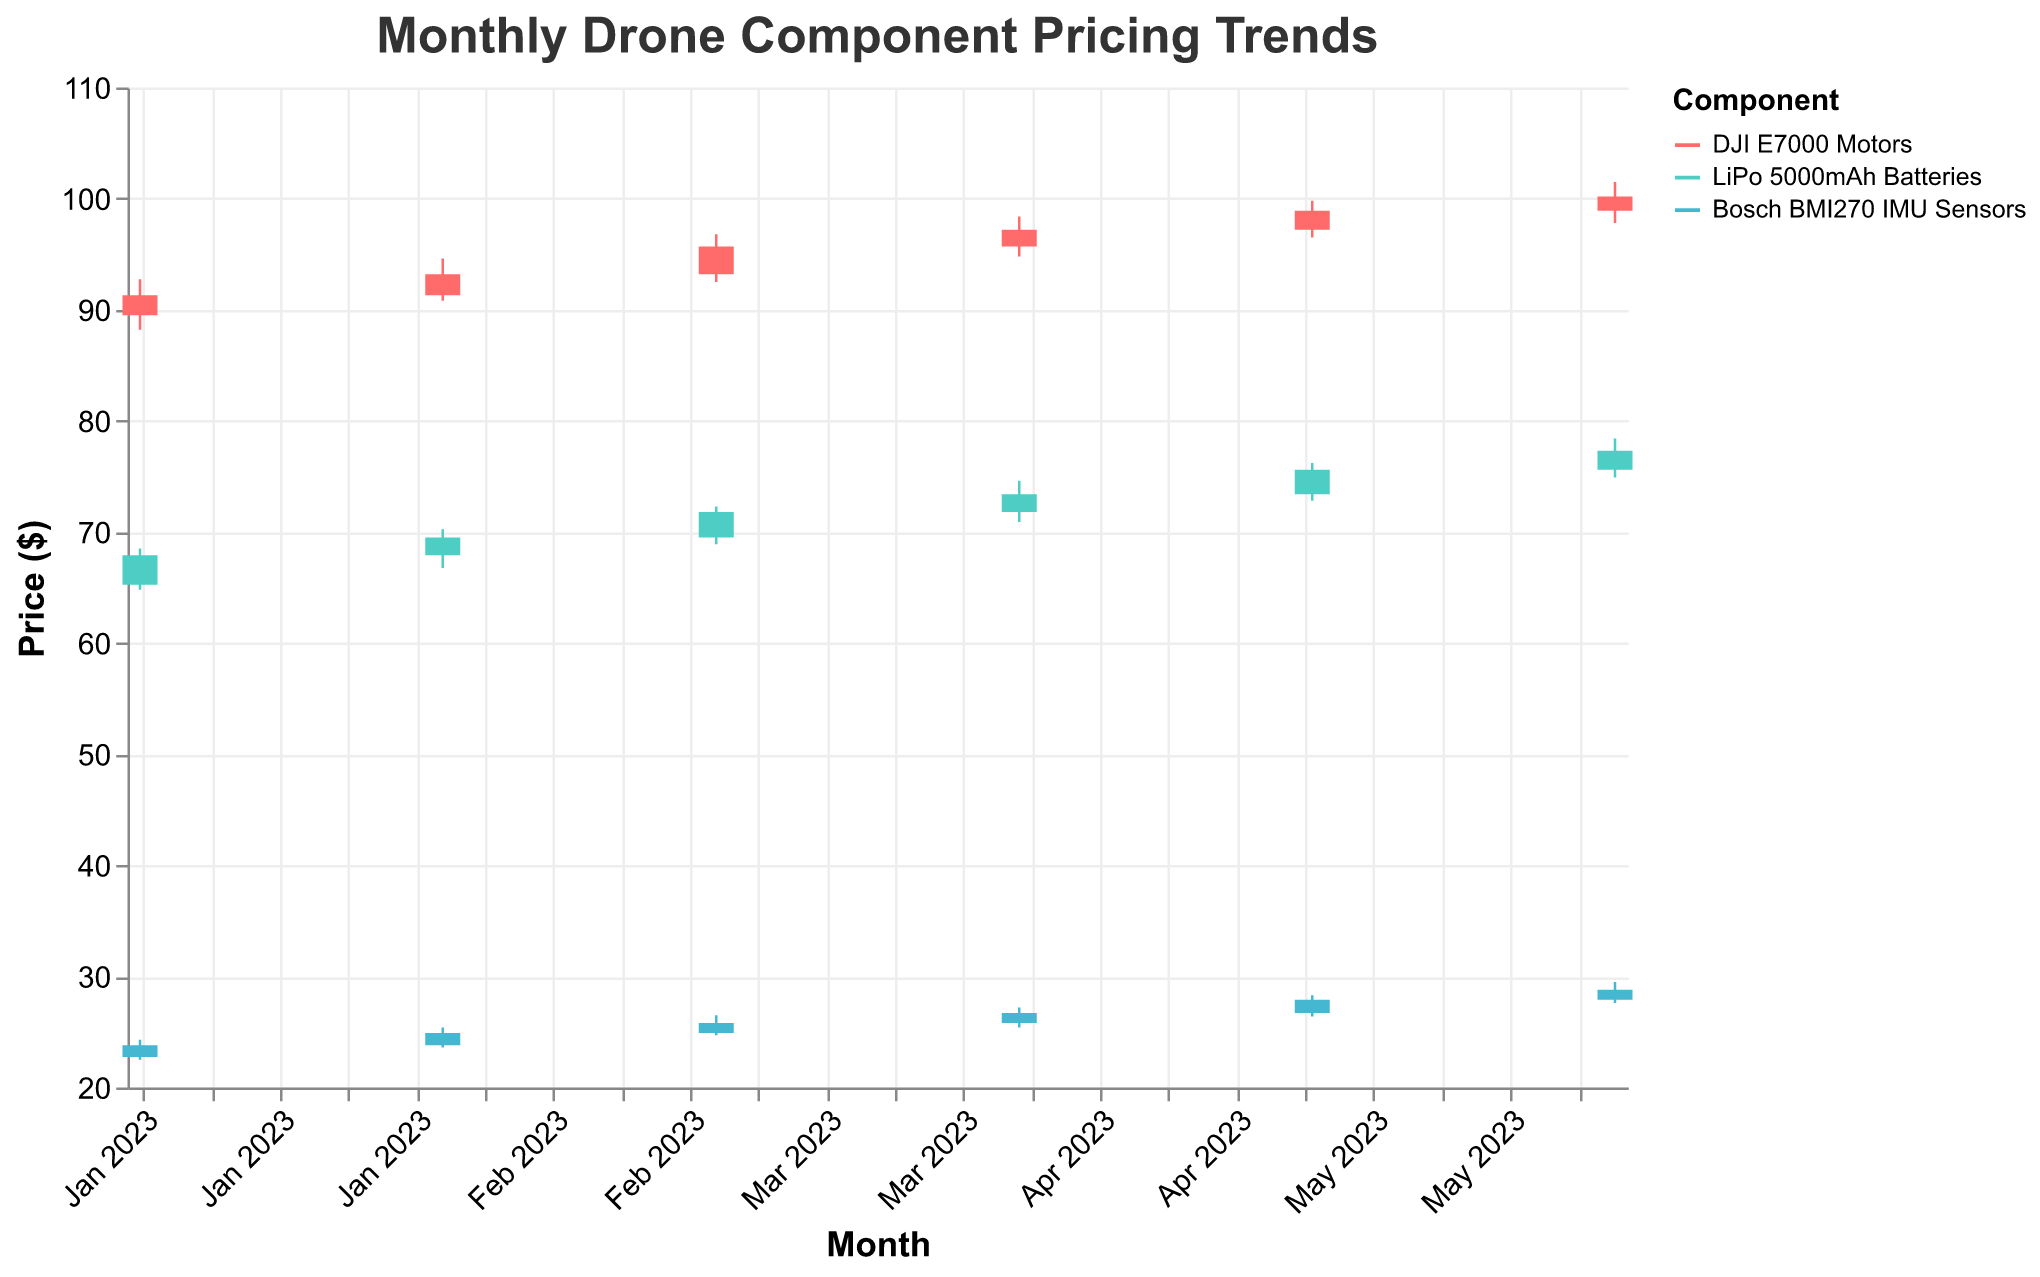What is the title of the chart? The title of the chart is displayed at the top part of the figure. It summarizes the topic or data being presented in the chart.
Answer: Monthly Drone Component Pricing Trends Which component had the highest price in June 2023? To identify the highest price for a component, look at the 'High' values for June 2023. Compare the high values for DJI E7000 Motors, LiPo 5000mAh Batteries, and Bosch BMI270 IMU Sensors. The DJI E7000 Motors had the highest price.
Answer: DJI E7000 Motors What is the average closing price for LiPo 5000mAh Batteries over the six months? To find the average closing price for LiPo 5000mAh Batteries, sum up the closing prices for each month and divide by the number of months: (67.90 + 69.50 + 71.80 + 73.40 + 75.60 + 77.30) / 6 = 72.58
Answer: 72.58 How did the closing price of Bosch BMI270 IMU Sensors change from January to June 2023? To determine the change, subtract the closing price in January from the closing price in June. Closing in January is 23.80, and closing in June is 28.80. 28.80 - 23.80 = 5.00
Answer: Increased by 5.00 Which component experienced the highest increase in closing price from January to February 2023? Calculate the difference in closing prices from January to February for each component. DJI E7000 Motors: 93.20 - 91.30 = 1.90. LiPo 5000mAh Batteries: 69.50 - 67.90 = 1.60. Bosch BMI270 IMU Sensors: 24.90 - 23.80 = 1.10. DJI E7000 Motors had the highest increase.
Answer: DJI E7000 Motors What was the lowest recorded price for the DJI E7000 Motors in the first half of 2023? Identify the 'Low' prices for DJI E7000 Motors from January to June and find the minimum value, which is 88.20 in January 2023.
Answer: 88.20 Between March and April 2023, did the closing price of the LiPo 5000mAh Batteries increase or decrease? Look at the closing prices for LiPo 5000mAh Batteries in March (71.80) and April (73.40). Compare the values to see if there was an increase or decrease.
Answer: Increased Which month had the highest 'High' value for Bosch BMI270 IMU Sensors in the first half of 2023? Compare the 'High' values for Bosch BMI270 IMU Sensors from January to June. Identify the month with the highest value. May 2023 had the highest value at 28.30.
Answer: May 2023 What was the closing price of DJI E7000 Motors in May 2023? Refer to the figure, find the data point for DJI E7000 Motors in May 2023, and check the 'Close' value.
Answer: 98.90 